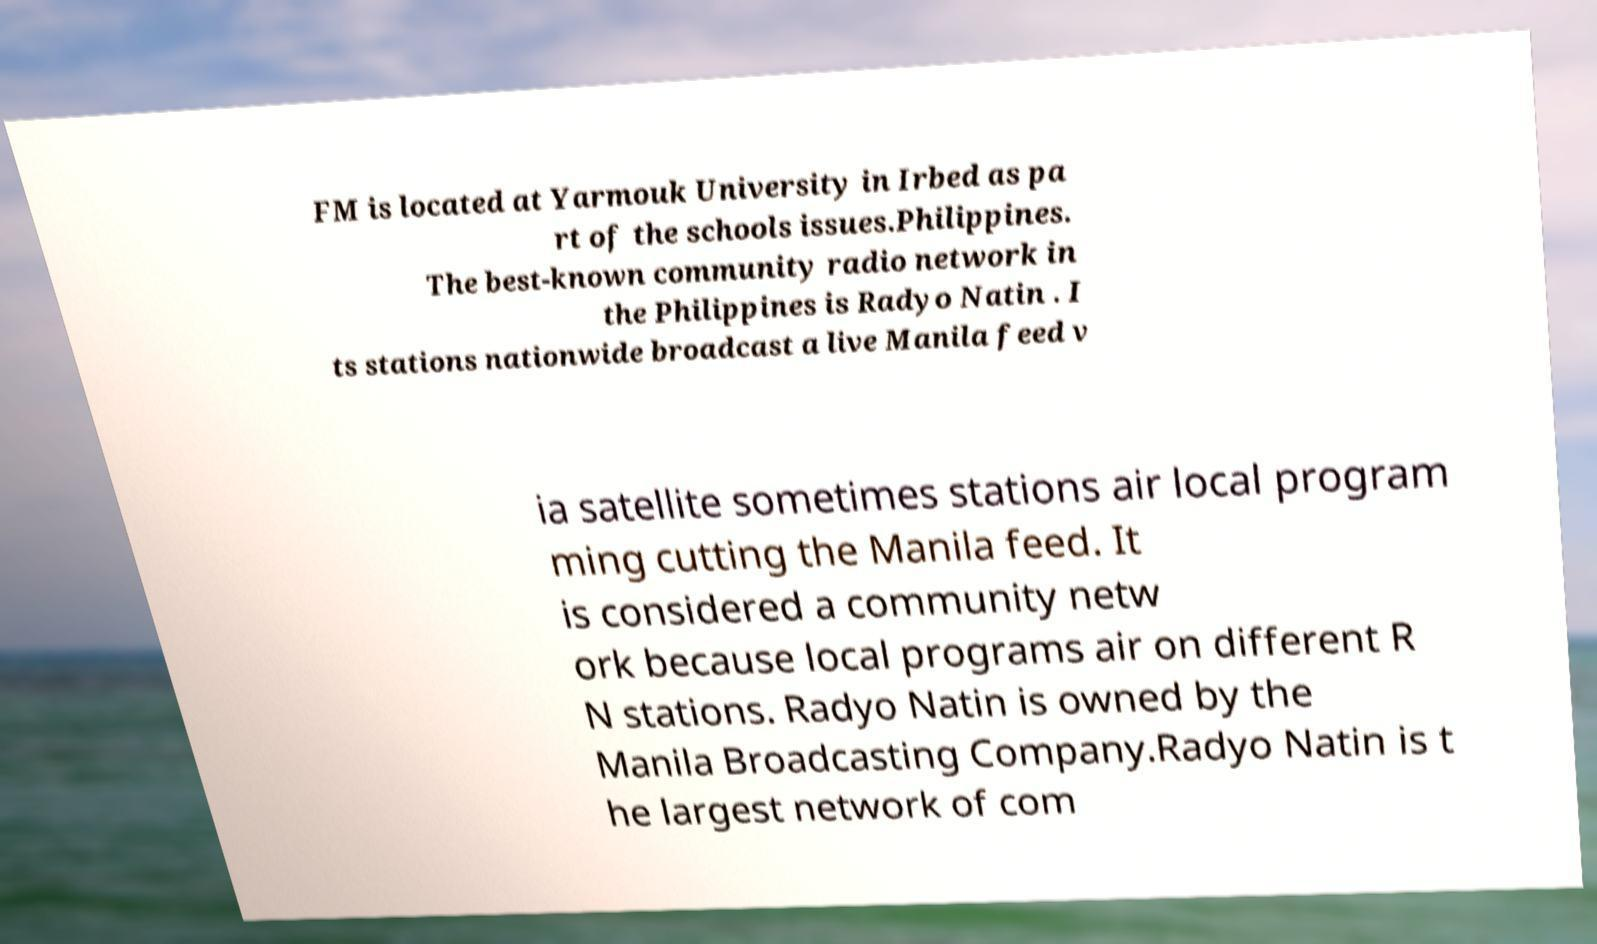Can you read and provide the text displayed in the image?This photo seems to have some interesting text. Can you extract and type it out for me? FM is located at Yarmouk University in Irbed as pa rt of the schools issues.Philippines. The best-known community radio network in the Philippines is Radyo Natin . I ts stations nationwide broadcast a live Manila feed v ia satellite sometimes stations air local program ming cutting the Manila feed. It is considered a community netw ork because local programs air on different R N stations. Radyo Natin is owned by the Manila Broadcasting Company.Radyo Natin is t he largest network of com 